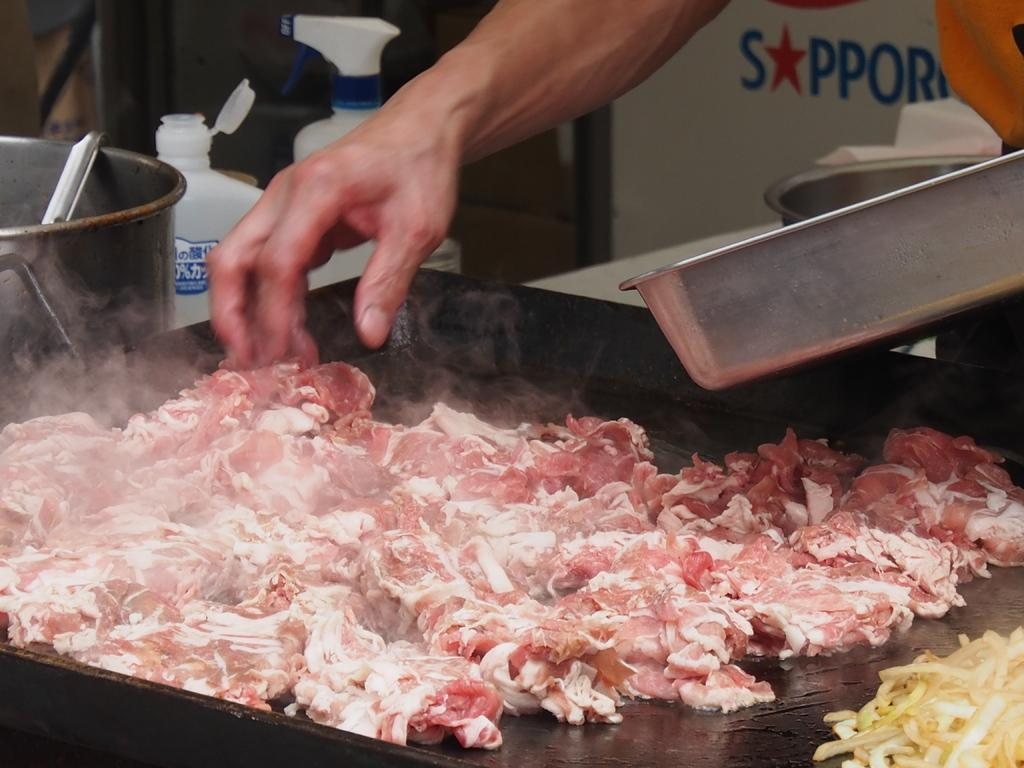What is being cooked in the image? There is meat placed on a cooking pan in the image. Can you describe anything else visible in the background of the image? A person's hand, a ladle, and plastic containers are visible in the background of the image. What type of utensils can be seen in the background? Utensils are present in the background of the image. What type of drum is being played by the person's sister in the image? There is no drum or sister present in the image. What kind of shock is the person experiencing while cooking in the image? There is no indication of a shock or any negative experience in the image; the person is simply cooking meat on a pan. 